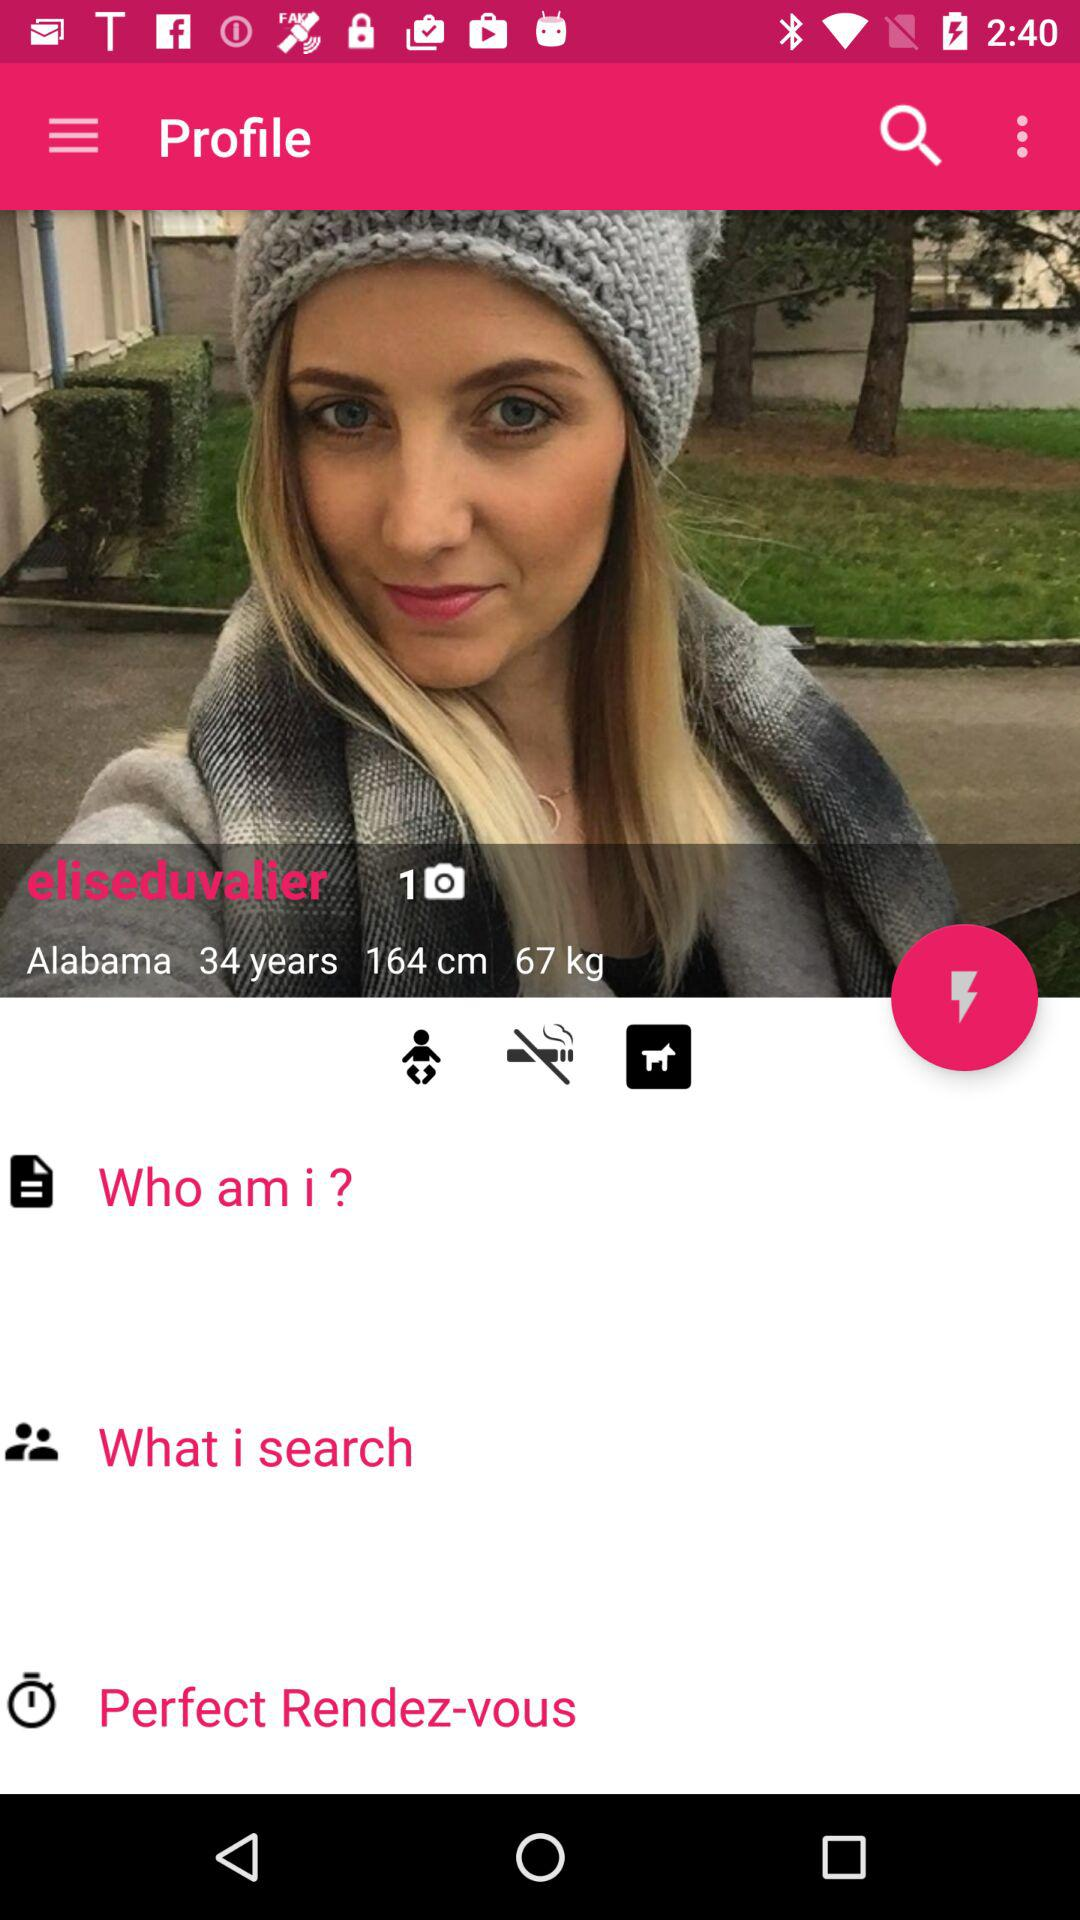What's the height of the girl? The girl's height is 164 cm. 